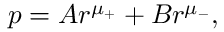<formula> <loc_0><loc_0><loc_500><loc_500>p = A r ^ { \mu _ { + } } + B r ^ { \mu _ { - } } ,</formula> 